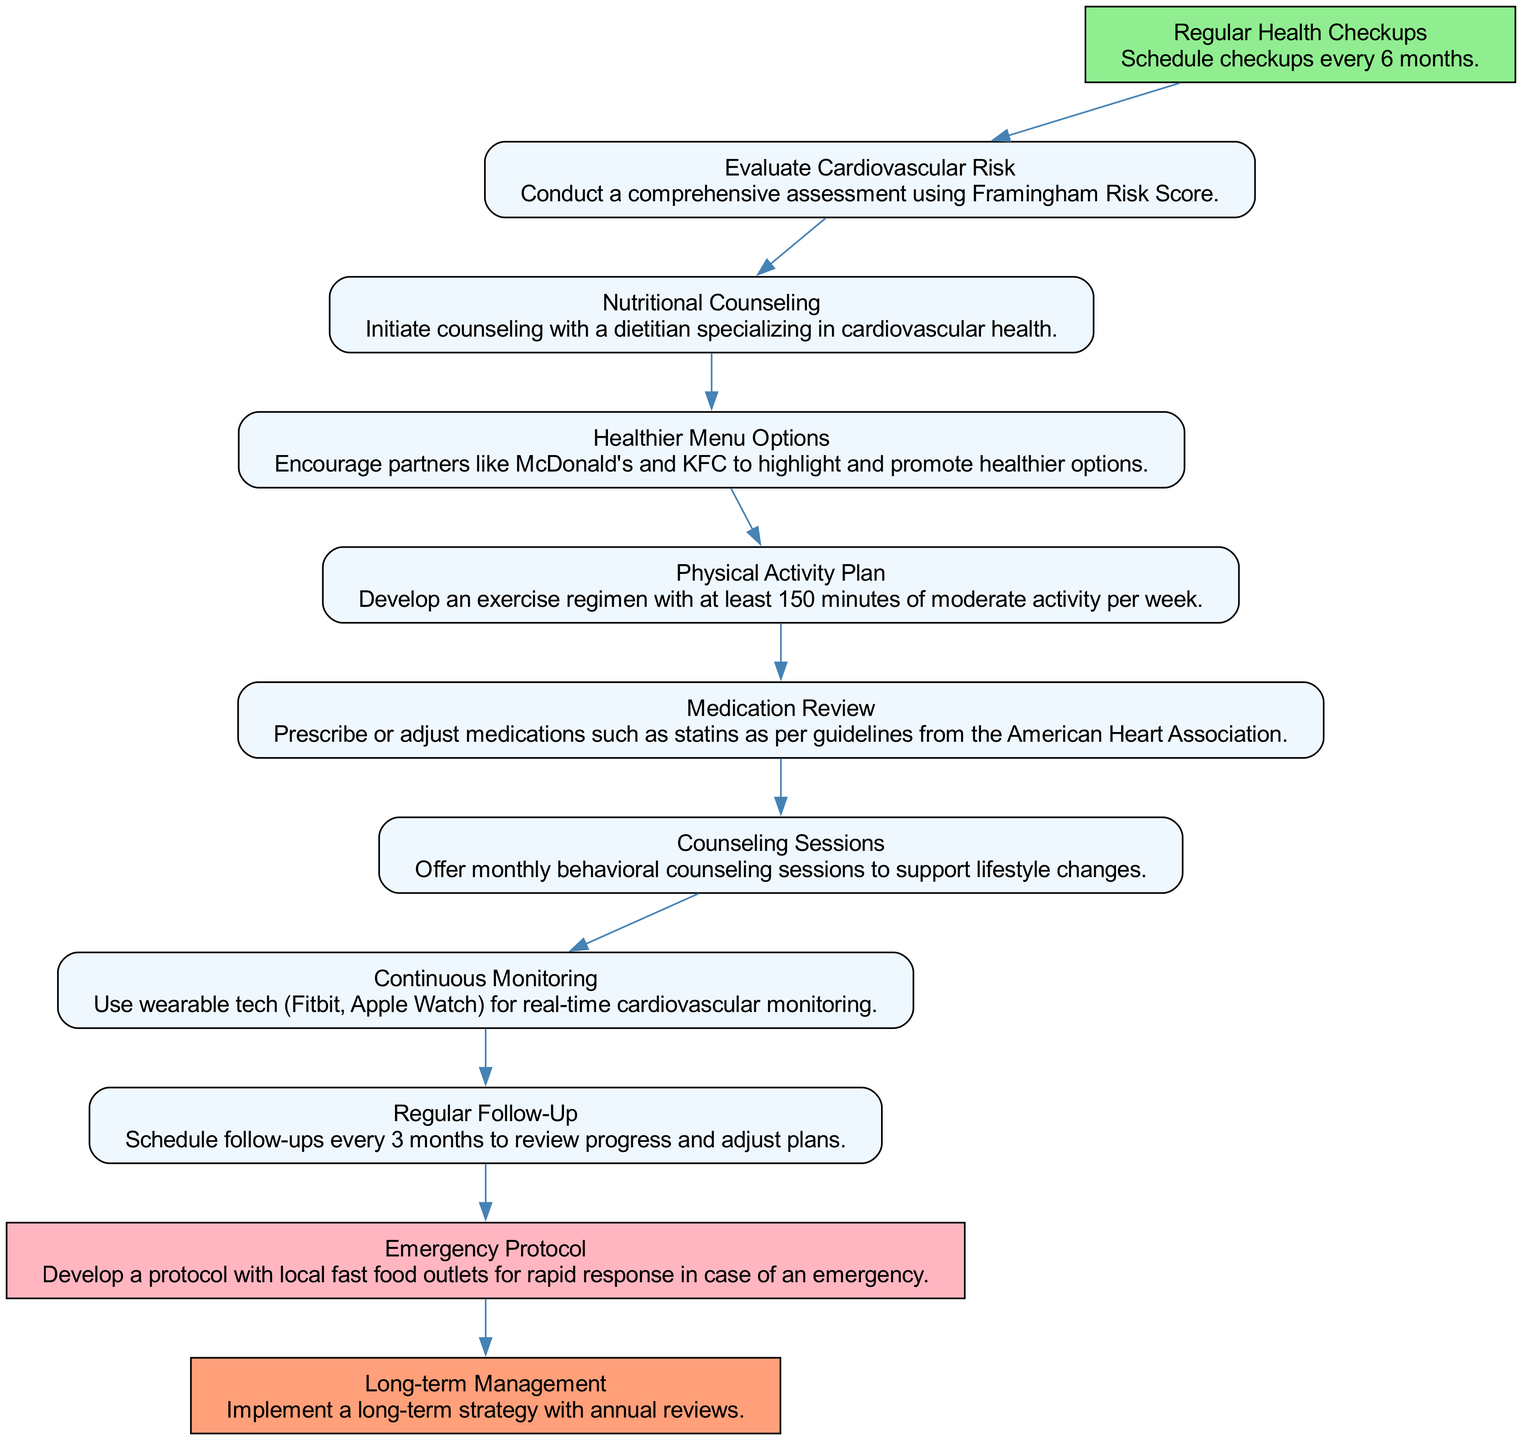What is the first step in the pathway? The diagram outlines the clinical pathway, starting from "Regular Health Checkups." This is evident as it is the first node in the flowchart.
Answer: Regular Health Checkups How often should health checkups be scheduled according to the diagram? The description in the "Regular Health Checkups" node states that checkups should be scheduled every 6 months. This specific time frame is included in the node's information.
Answer: Every 6 months What is recommended for physical activity? The "Physical Activity Plan" node indicates the requirement to develop an exercise regimen with at least 150 minutes of moderate activity weekly. This is a clear statement within that node.
Answer: 150 minutes What is the purpose of the Emergency Protocol step? The "Emergency Protocol" node describes developing a protocol with local fast food outlets for rapid response in case of an emergency. This outlines the node's primary objective as seen in its description.
Answer: Rapid response What step follows "Nutritional Counseling"? Looking at the flowchart, after "Nutritional Counseling," the next step is "Healthier Menu Options," as indicated by the connecting edge between these nodes.
Answer: Healthier Menu Options How many times should follow-ups be scheduled in a year? The "Regular Follow-Up" step mentions scheduling follow-ups every 3 months. To find the total number of follow-ups, one would divide the year into 3-month segments, resulting in 4 follow-ups per year.
Answer: 4 What is the last step in the Clinical Pathway? As noted in the diagram, the final node is "Long-term Management," which signifies the end point of the pathway. This is clear from its position as the last node.
Answer: Long-term Management What technology is suggested for continuous monitoring? The "Continuous Monitoring" node indicates the use of wearable technology such as Fitbit and Apple Watch for real-time cardiovascular monitoring, which defines the type of tools recommended.
Answer: Wearable tech What is the main role of Behavioral Support in this pathway? The "Counseling Sessions" node outlines offering monthly behavioral counseling to support lifestyle changes specifically, which reflects the purpose and function of this step in the pathway.
Answer: Support lifestyle changes 